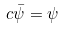Convert formula to latex. <formula><loc_0><loc_0><loc_500><loc_500>c \bar { \psi } = \psi</formula> 